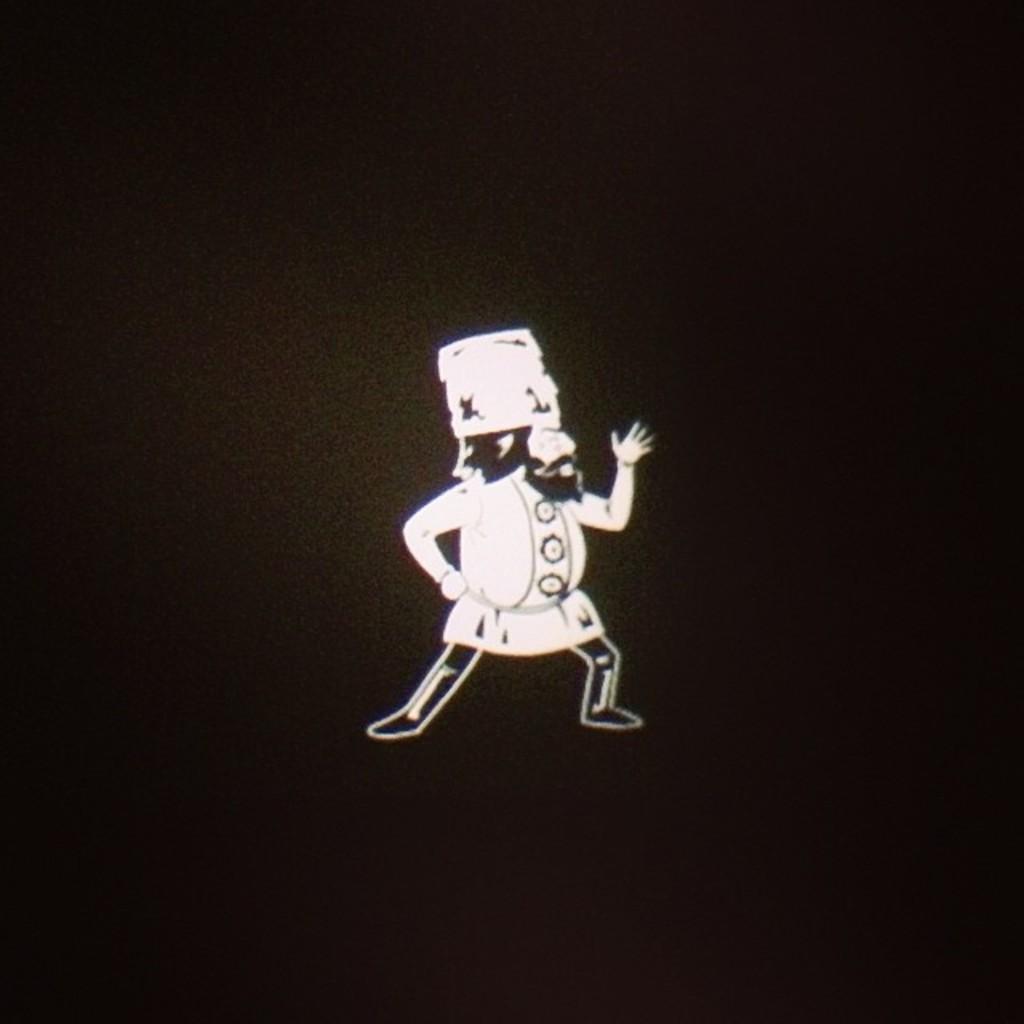Can you describe this image briefly? In this image I can see a person in black and white color. Background is in black color. 